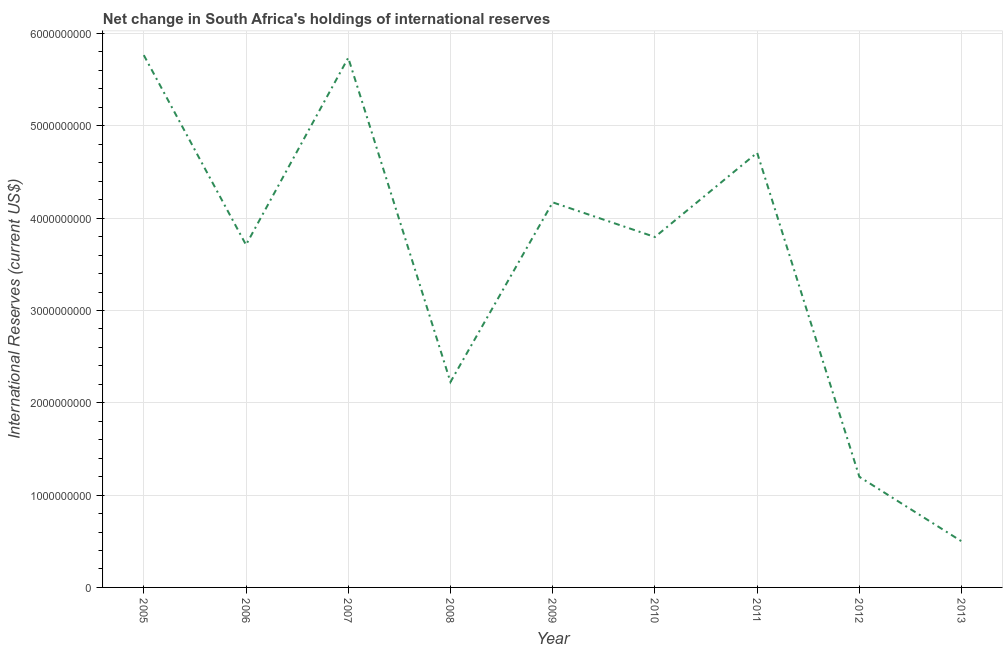What is the reserves and related items in 2007?
Give a very brief answer. 5.74e+09. Across all years, what is the maximum reserves and related items?
Your answer should be compact. 5.77e+09. Across all years, what is the minimum reserves and related items?
Provide a succinct answer. 4.99e+08. In which year was the reserves and related items maximum?
Offer a terse response. 2005. What is the sum of the reserves and related items?
Provide a short and direct response. 3.18e+1. What is the difference between the reserves and related items in 2006 and 2007?
Make the answer very short. -2.03e+09. What is the average reserves and related items per year?
Provide a short and direct response. 3.53e+09. What is the median reserves and related items?
Make the answer very short. 3.80e+09. In how many years, is the reserves and related items greater than 2600000000 US$?
Offer a terse response. 6. What is the ratio of the reserves and related items in 2005 to that in 2008?
Provide a succinct answer. 2.59. Is the reserves and related items in 2005 less than that in 2007?
Ensure brevity in your answer.  No. Is the difference between the reserves and related items in 2010 and 2011 greater than the difference between any two years?
Provide a short and direct response. No. What is the difference between the highest and the second highest reserves and related items?
Your response must be concise. 2.86e+07. What is the difference between the highest and the lowest reserves and related items?
Your answer should be very brief. 5.27e+09. How many lines are there?
Give a very brief answer. 1. What is the difference between two consecutive major ticks on the Y-axis?
Keep it short and to the point. 1.00e+09. Are the values on the major ticks of Y-axis written in scientific E-notation?
Your answer should be very brief. No. Does the graph contain any zero values?
Provide a short and direct response. No. Does the graph contain grids?
Ensure brevity in your answer.  Yes. What is the title of the graph?
Offer a terse response. Net change in South Africa's holdings of international reserves. What is the label or title of the X-axis?
Keep it short and to the point. Year. What is the label or title of the Y-axis?
Make the answer very short. International Reserves (current US$). What is the International Reserves (current US$) of 2005?
Your answer should be very brief. 5.77e+09. What is the International Reserves (current US$) of 2006?
Your answer should be compact. 3.71e+09. What is the International Reserves (current US$) of 2007?
Your answer should be very brief. 5.74e+09. What is the International Reserves (current US$) in 2008?
Ensure brevity in your answer.  2.23e+09. What is the International Reserves (current US$) in 2009?
Provide a short and direct response. 4.17e+09. What is the International Reserves (current US$) in 2010?
Your answer should be compact. 3.80e+09. What is the International Reserves (current US$) in 2011?
Provide a succinct answer. 4.71e+09. What is the International Reserves (current US$) of 2012?
Provide a succinct answer. 1.20e+09. What is the International Reserves (current US$) of 2013?
Your answer should be compact. 4.99e+08. What is the difference between the International Reserves (current US$) in 2005 and 2006?
Ensure brevity in your answer.  2.05e+09. What is the difference between the International Reserves (current US$) in 2005 and 2007?
Offer a terse response. 2.86e+07. What is the difference between the International Reserves (current US$) in 2005 and 2008?
Make the answer very short. 3.54e+09. What is the difference between the International Reserves (current US$) in 2005 and 2009?
Ensure brevity in your answer.  1.59e+09. What is the difference between the International Reserves (current US$) in 2005 and 2010?
Your answer should be compact. 1.97e+09. What is the difference between the International Reserves (current US$) in 2005 and 2011?
Your answer should be compact. 1.06e+09. What is the difference between the International Reserves (current US$) in 2005 and 2012?
Keep it short and to the point. 4.57e+09. What is the difference between the International Reserves (current US$) in 2005 and 2013?
Make the answer very short. 5.27e+09. What is the difference between the International Reserves (current US$) in 2006 and 2007?
Your answer should be very brief. -2.03e+09. What is the difference between the International Reserves (current US$) in 2006 and 2008?
Make the answer very short. 1.49e+09. What is the difference between the International Reserves (current US$) in 2006 and 2009?
Offer a terse response. -4.60e+08. What is the difference between the International Reserves (current US$) in 2006 and 2010?
Provide a short and direct response. -8.50e+07. What is the difference between the International Reserves (current US$) in 2006 and 2011?
Provide a short and direct response. -9.98e+08. What is the difference between the International Reserves (current US$) in 2006 and 2012?
Make the answer very short. 2.51e+09. What is the difference between the International Reserves (current US$) in 2006 and 2013?
Your response must be concise. 3.21e+09. What is the difference between the International Reserves (current US$) in 2007 and 2008?
Provide a short and direct response. 3.51e+09. What is the difference between the International Reserves (current US$) in 2007 and 2009?
Your answer should be compact. 1.57e+09. What is the difference between the International Reserves (current US$) in 2007 and 2010?
Offer a very short reply. 1.94e+09. What is the difference between the International Reserves (current US$) in 2007 and 2011?
Provide a succinct answer. 1.03e+09. What is the difference between the International Reserves (current US$) in 2007 and 2012?
Provide a succinct answer. 4.54e+09. What is the difference between the International Reserves (current US$) in 2007 and 2013?
Your answer should be very brief. 5.24e+09. What is the difference between the International Reserves (current US$) in 2008 and 2009?
Provide a short and direct response. -1.95e+09. What is the difference between the International Reserves (current US$) in 2008 and 2010?
Provide a succinct answer. -1.57e+09. What is the difference between the International Reserves (current US$) in 2008 and 2011?
Ensure brevity in your answer.  -2.48e+09. What is the difference between the International Reserves (current US$) in 2008 and 2012?
Offer a very short reply. 1.03e+09. What is the difference between the International Reserves (current US$) in 2008 and 2013?
Provide a short and direct response. 1.73e+09. What is the difference between the International Reserves (current US$) in 2009 and 2010?
Provide a succinct answer. 3.75e+08. What is the difference between the International Reserves (current US$) in 2009 and 2011?
Make the answer very short. -5.38e+08. What is the difference between the International Reserves (current US$) in 2009 and 2012?
Ensure brevity in your answer.  2.97e+09. What is the difference between the International Reserves (current US$) in 2009 and 2013?
Provide a short and direct response. 3.67e+09. What is the difference between the International Reserves (current US$) in 2010 and 2011?
Make the answer very short. -9.13e+08. What is the difference between the International Reserves (current US$) in 2010 and 2012?
Your answer should be compact. 2.60e+09. What is the difference between the International Reserves (current US$) in 2010 and 2013?
Offer a very short reply. 3.30e+09. What is the difference between the International Reserves (current US$) in 2011 and 2012?
Offer a very short reply. 3.51e+09. What is the difference between the International Reserves (current US$) in 2011 and 2013?
Your answer should be compact. 4.21e+09. What is the difference between the International Reserves (current US$) in 2012 and 2013?
Your answer should be compact. 6.99e+08. What is the ratio of the International Reserves (current US$) in 2005 to that in 2006?
Offer a terse response. 1.55. What is the ratio of the International Reserves (current US$) in 2005 to that in 2007?
Your answer should be compact. 1. What is the ratio of the International Reserves (current US$) in 2005 to that in 2008?
Make the answer very short. 2.59. What is the ratio of the International Reserves (current US$) in 2005 to that in 2009?
Make the answer very short. 1.38. What is the ratio of the International Reserves (current US$) in 2005 to that in 2010?
Offer a terse response. 1.52. What is the ratio of the International Reserves (current US$) in 2005 to that in 2011?
Keep it short and to the point. 1.22. What is the ratio of the International Reserves (current US$) in 2005 to that in 2012?
Provide a succinct answer. 4.81. What is the ratio of the International Reserves (current US$) in 2005 to that in 2013?
Make the answer very short. 11.55. What is the ratio of the International Reserves (current US$) in 2006 to that in 2007?
Keep it short and to the point. 0.65. What is the ratio of the International Reserves (current US$) in 2006 to that in 2008?
Ensure brevity in your answer.  1.67. What is the ratio of the International Reserves (current US$) in 2006 to that in 2009?
Your answer should be compact. 0.89. What is the ratio of the International Reserves (current US$) in 2006 to that in 2010?
Keep it short and to the point. 0.98. What is the ratio of the International Reserves (current US$) in 2006 to that in 2011?
Offer a terse response. 0.79. What is the ratio of the International Reserves (current US$) in 2006 to that in 2012?
Provide a short and direct response. 3.1. What is the ratio of the International Reserves (current US$) in 2006 to that in 2013?
Offer a terse response. 7.43. What is the ratio of the International Reserves (current US$) in 2007 to that in 2008?
Provide a short and direct response. 2.58. What is the ratio of the International Reserves (current US$) in 2007 to that in 2009?
Give a very brief answer. 1.38. What is the ratio of the International Reserves (current US$) in 2007 to that in 2010?
Provide a short and direct response. 1.51. What is the ratio of the International Reserves (current US$) in 2007 to that in 2011?
Provide a short and direct response. 1.22. What is the ratio of the International Reserves (current US$) in 2007 to that in 2012?
Make the answer very short. 4.79. What is the ratio of the International Reserves (current US$) in 2007 to that in 2013?
Make the answer very short. 11.5. What is the ratio of the International Reserves (current US$) in 2008 to that in 2009?
Your answer should be compact. 0.53. What is the ratio of the International Reserves (current US$) in 2008 to that in 2010?
Your answer should be compact. 0.59. What is the ratio of the International Reserves (current US$) in 2008 to that in 2011?
Offer a terse response. 0.47. What is the ratio of the International Reserves (current US$) in 2008 to that in 2012?
Offer a very short reply. 1.86. What is the ratio of the International Reserves (current US$) in 2008 to that in 2013?
Give a very brief answer. 4.46. What is the ratio of the International Reserves (current US$) in 2009 to that in 2010?
Your response must be concise. 1.1. What is the ratio of the International Reserves (current US$) in 2009 to that in 2011?
Offer a terse response. 0.89. What is the ratio of the International Reserves (current US$) in 2009 to that in 2012?
Ensure brevity in your answer.  3.48. What is the ratio of the International Reserves (current US$) in 2009 to that in 2013?
Offer a very short reply. 8.36. What is the ratio of the International Reserves (current US$) in 2010 to that in 2011?
Make the answer very short. 0.81. What is the ratio of the International Reserves (current US$) in 2010 to that in 2012?
Your response must be concise. 3.17. What is the ratio of the International Reserves (current US$) in 2010 to that in 2013?
Your answer should be very brief. 7.61. What is the ratio of the International Reserves (current US$) in 2011 to that in 2012?
Your answer should be very brief. 3.93. What is the ratio of the International Reserves (current US$) in 2011 to that in 2013?
Make the answer very short. 9.44. What is the ratio of the International Reserves (current US$) in 2012 to that in 2013?
Your response must be concise. 2.4. 